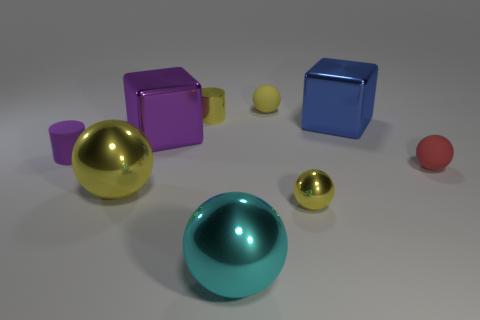There is a yellow cylinder that is the same material as the big cyan ball; what is its size? The yellow cylinder appears to be small, especially when compared to the big cyan ball. Estimating from this perspective, it's considerably more diminutive in both height and diameter. 